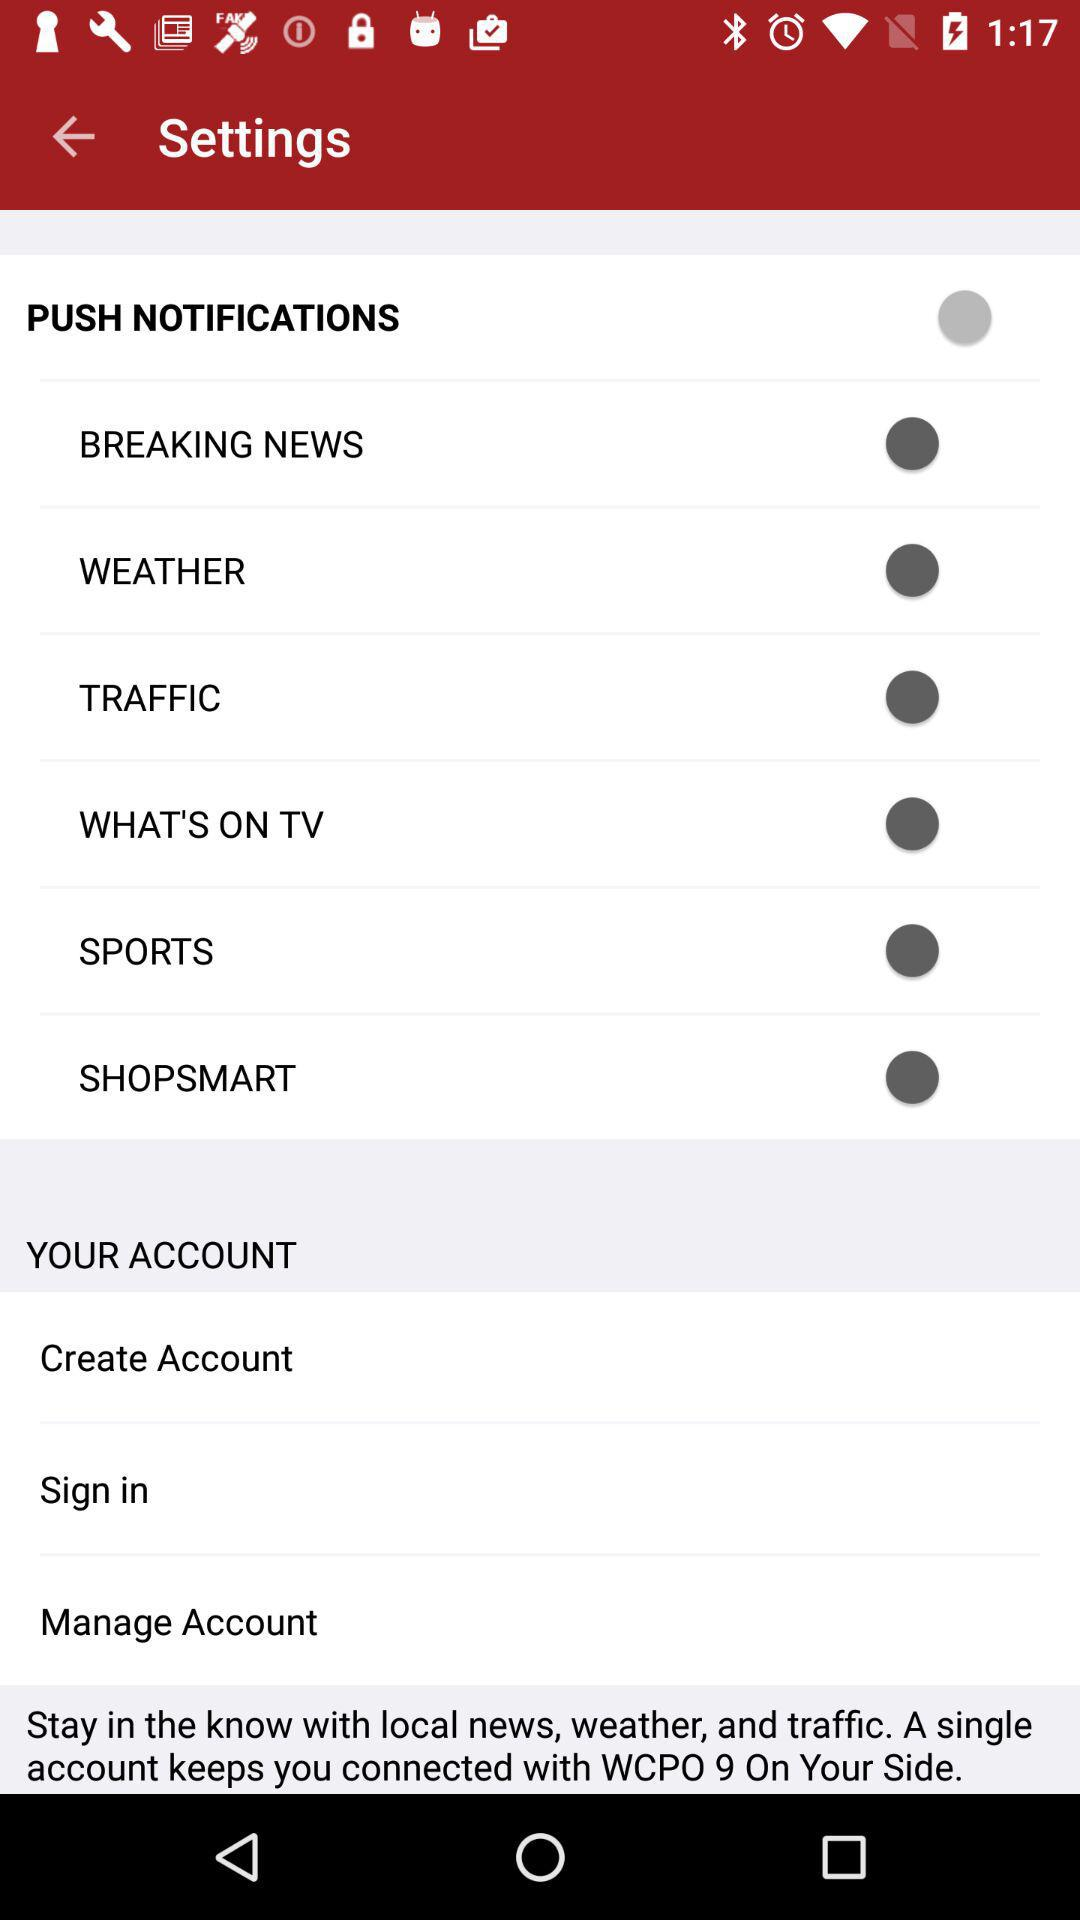What is the status of "TRAFFIC"? The status is "off". 